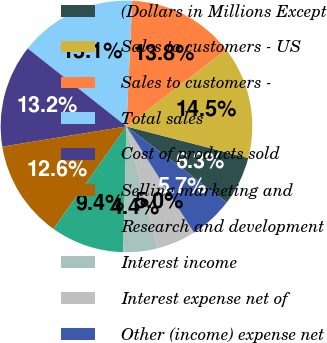Convert chart. <chart><loc_0><loc_0><loc_500><loc_500><pie_chart><fcel>(Dollars in Millions Except<fcel>Sales to customers - US<fcel>Sales to customers -<fcel>Total sales<fcel>Cost of products sold<fcel>Selling marketing and<fcel>Research and development<fcel>Interest income<fcel>Interest expense net of<fcel>Other (income) expense net<nl><fcel>6.29%<fcel>14.47%<fcel>13.84%<fcel>15.09%<fcel>13.21%<fcel>12.58%<fcel>9.43%<fcel>4.4%<fcel>5.03%<fcel>5.66%<nl></chart> 